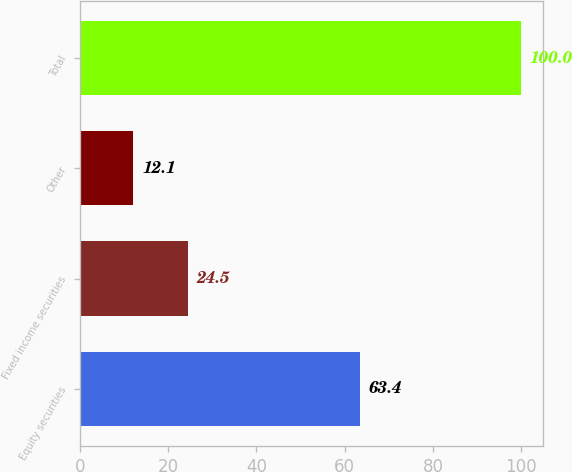Convert chart. <chart><loc_0><loc_0><loc_500><loc_500><bar_chart><fcel>Equity securities<fcel>Fixed income securities<fcel>Other<fcel>Total<nl><fcel>63.4<fcel>24.5<fcel>12.1<fcel>100<nl></chart> 